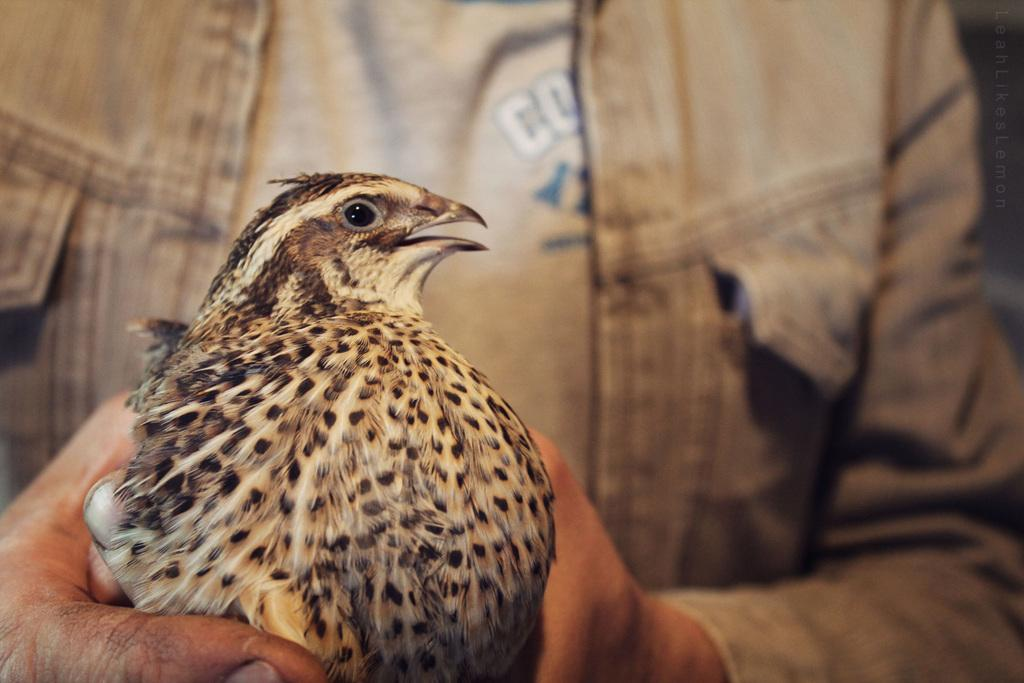What type of animal is in the image? There is a bird in the image. How is the bird being held in the image? The bird is being held by a person. Where is this scene located in the image? This scene is in the foreground of the image. What type of texture can be seen on the pig in the image? There is no pig present in the image; it features a bird being held by a person. What appliance is being used by the bird in the image? There is no appliance being used by the bird in the image; it is simply being held by a person. 